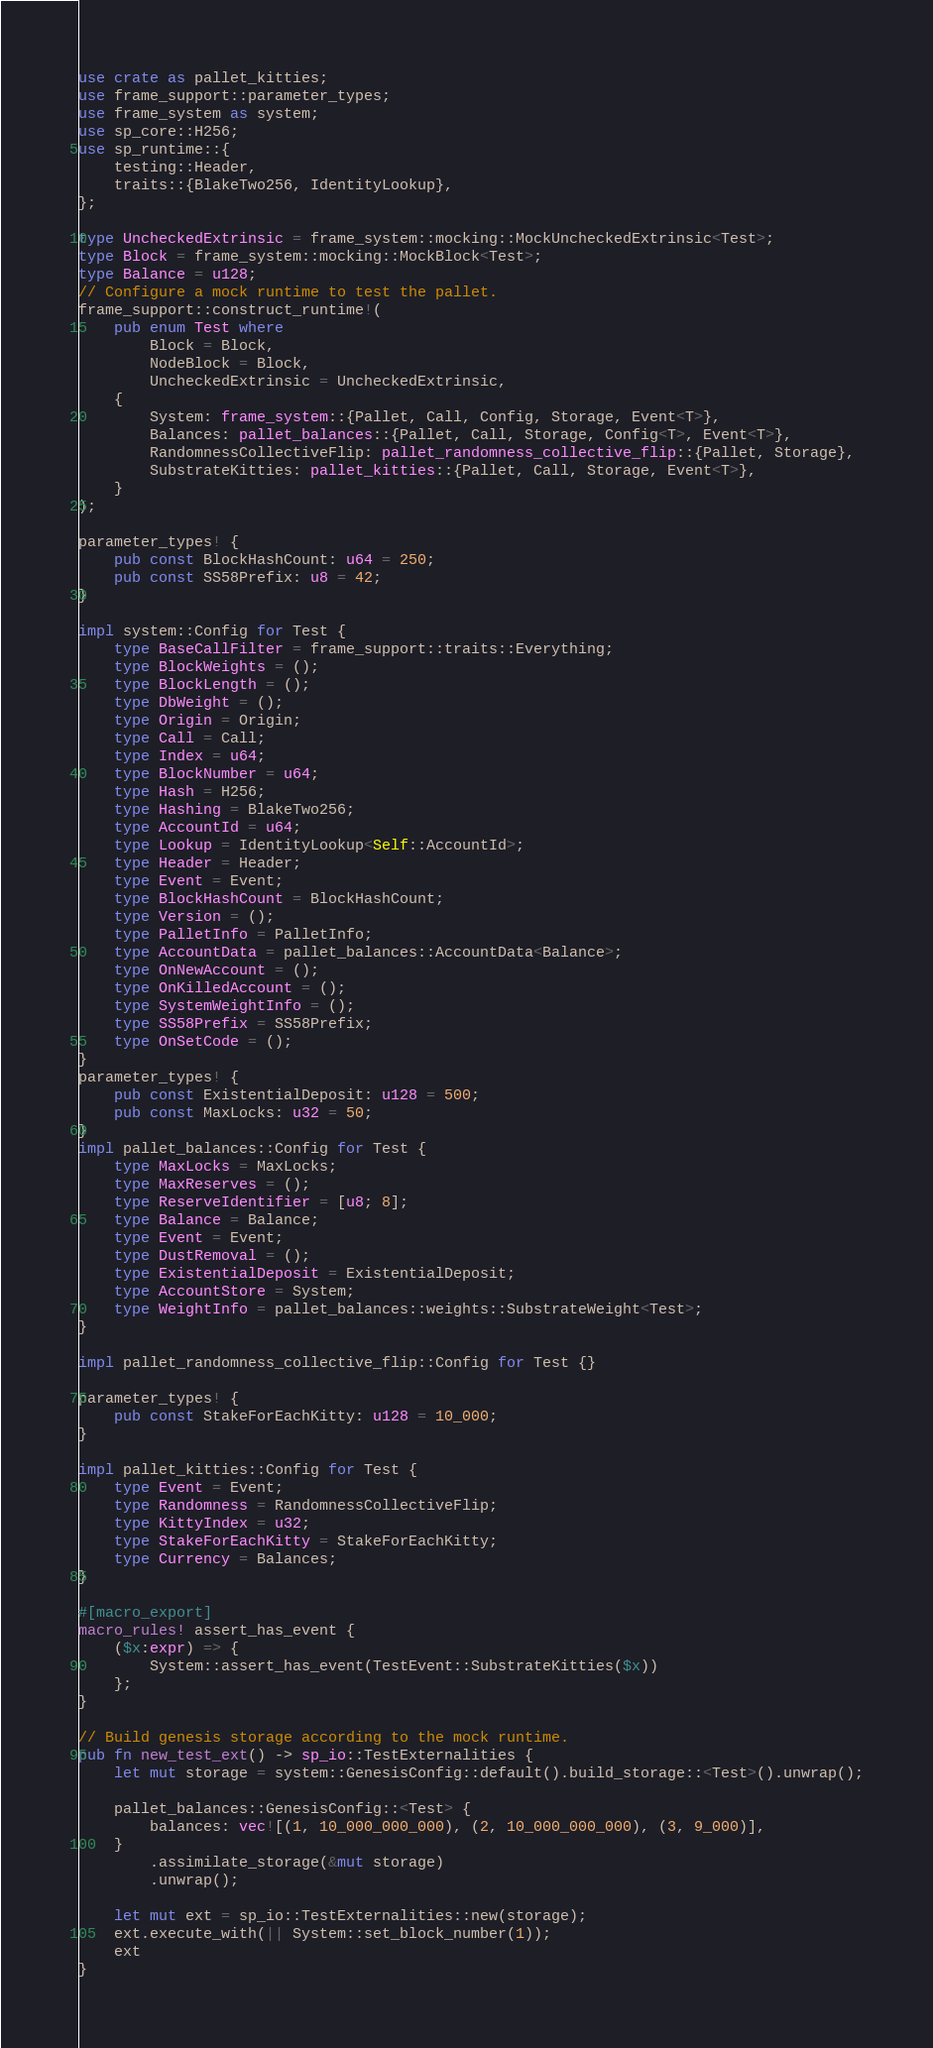Convert code to text. <code><loc_0><loc_0><loc_500><loc_500><_Rust_>use crate as pallet_kitties;
use frame_support::parameter_types;
use frame_system as system;
use sp_core::H256;
use sp_runtime::{
	testing::Header,
	traits::{BlakeTwo256, IdentityLookup},
};

type UncheckedExtrinsic = frame_system::mocking::MockUncheckedExtrinsic<Test>;
type Block = frame_system::mocking::MockBlock<Test>;
type Balance = u128;
// Configure a mock runtime to test the pallet.
frame_support::construct_runtime!(
	pub enum Test where
		Block = Block,
		NodeBlock = Block,
		UncheckedExtrinsic = UncheckedExtrinsic,
	{
		System: frame_system::{Pallet, Call, Config, Storage, Event<T>},
		Balances: pallet_balances::{Pallet, Call, Storage, Config<T>, Event<T>},
		RandomnessCollectiveFlip: pallet_randomness_collective_flip::{Pallet, Storage},
		SubstrateKitties: pallet_kitties::{Pallet, Call, Storage, Event<T>},
	}
);

parameter_types! {
	pub const BlockHashCount: u64 = 250;
	pub const SS58Prefix: u8 = 42;
}

impl system::Config for Test {
	type BaseCallFilter = frame_support::traits::Everything;
	type BlockWeights = ();
	type BlockLength = ();
	type DbWeight = ();
	type Origin = Origin;
	type Call = Call;
	type Index = u64;
	type BlockNumber = u64;
	type Hash = H256;
	type Hashing = BlakeTwo256;
	type AccountId = u64;
	type Lookup = IdentityLookup<Self::AccountId>;
	type Header = Header;
	type Event = Event;
	type BlockHashCount = BlockHashCount;
	type Version = ();
	type PalletInfo = PalletInfo;
	type AccountData = pallet_balances::AccountData<Balance>;
	type OnNewAccount = ();
	type OnKilledAccount = ();
	type SystemWeightInfo = ();
	type SS58Prefix = SS58Prefix;
	type OnSetCode = ();
}
parameter_types! {
	pub const ExistentialDeposit: u128 = 500;
	pub const MaxLocks: u32 = 50;
}
impl pallet_balances::Config for Test {
	type MaxLocks = MaxLocks;
	type MaxReserves = ();
	type ReserveIdentifier = [u8; 8];
	type Balance = Balance;
	type Event = Event;
	type DustRemoval = ();
	type ExistentialDeposit = ExistentialDeposit;
	type AccountStore = System;
	type WeightInfo = pallet_balances::weights::SubstrateWeight<Test>;
}

impl pallet_randomness_collective_flip::Config for Test {}

parameter_types! {
	pub const StakeForEachKitty: u128 = 10_000;
}

impl pallet_kitties::Config for Test {
	type Event = Event;
	type Randomness = RandomnessCollectiveFlip;
	type KittyIndex = u32;
	type StakeForEachKitty = StakeForEachKitty;
	type Currency = Balances;
}

#[macro_export]
macro_rules! assert_has_event {
	($x:expr) => {
		System::assert_has_event(TestEvent::SubstrateKitties($x))
	};
}

// Build genesis storage according to the mock runtime.
pub fn new_test_ext() -> sp_io::TestExternalities {
	let mut storage = system::GenesisConfig::default().build_storage::<Test>().unwrap();

	pallet_balances::GenesisConfig::<Test> {
		balances: vec![(1, 10_000_000_000), (2, 10_000_000_000), (3, 9_000)],
	}
		.assimilate_storage(&mut storage)
		.unwrap();

	let mut ext = sp_io::TestExternalities::new(storage);
	ext.execute_with(|| System::set_block_number(1));
	ext
}
</code> 